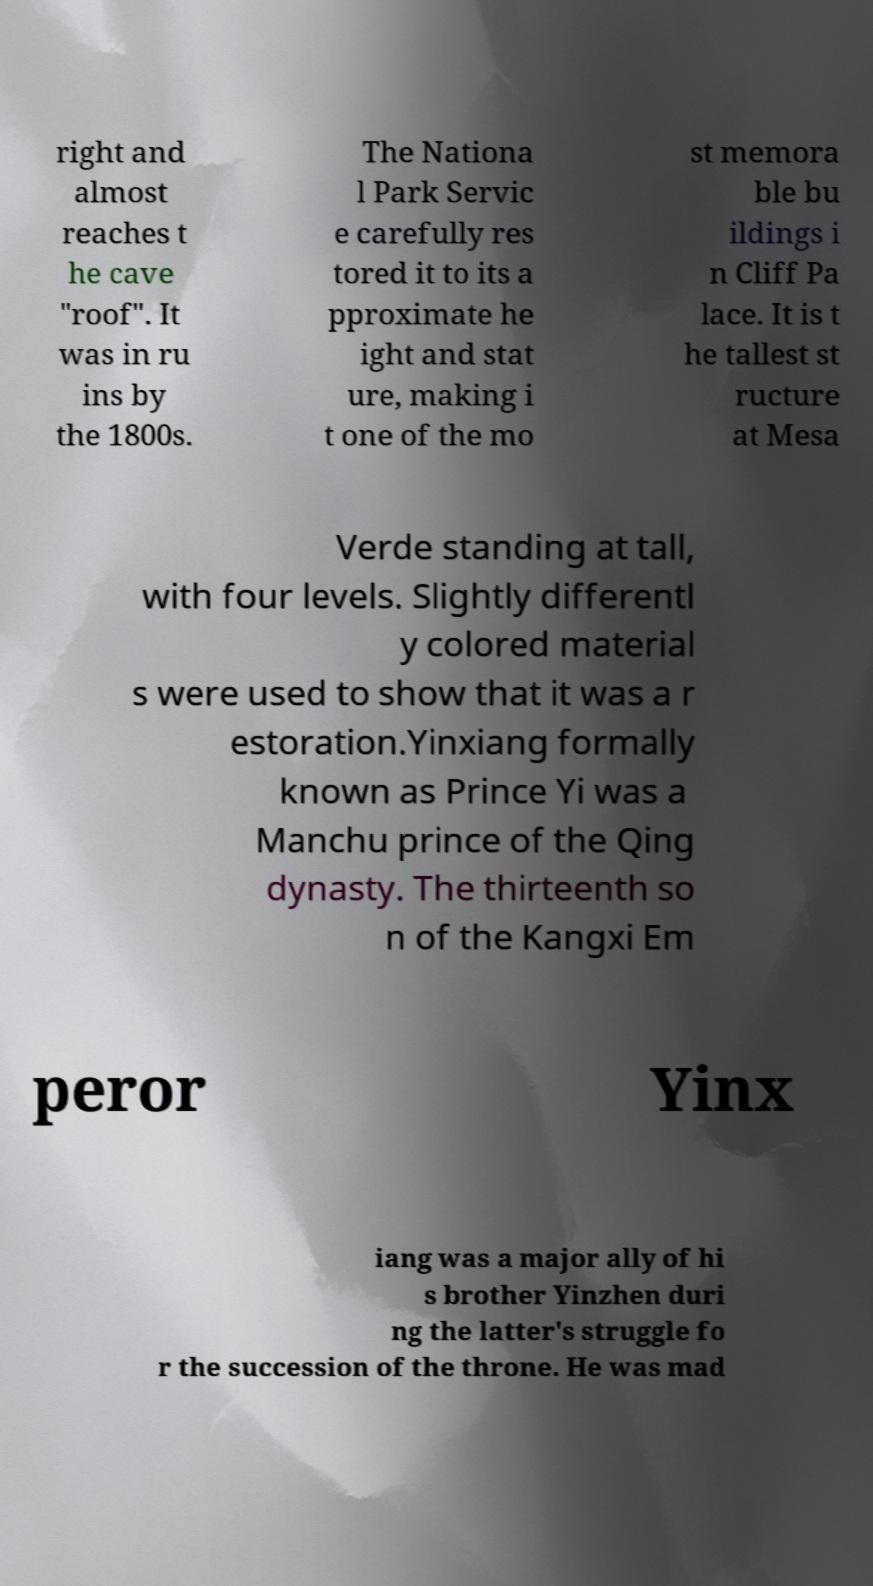For documentation purposes, I need the text within this image transcribed. Could you provide that? right and almost reaches t he cave "roof". It was in ru ins by the 1800s. The Nationa l Park Servic e carefully res tored it to its a pproximate he ight and stat ure, making i t one of the mo st memora ble bu ildings i n Cliff Pa lace. It is t he tallest st ructure at Mesa Verde standing at tall, with four levels. Slightly differentl y colored material s were used to show that it was a r estoration.Yinxiang formally known as Prince Yi was a Manchu prince of the Qing dynasty. The thirteenth so n of the Kangxi Em peror Yinx iang was a major ally of hi s brother Yinzhen duri ng the latter's struggle fo r the succession of the throne. He was mad 